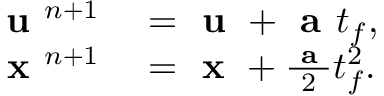<formula> <loc_0><loc_0><loc_500><loc_500>\begin{array} { r l } { u ^ { n + 1 } } & = u + a t _ { f } , } \\ { x ^ { n + 1 } } & = x + \frac { a } { 2 } t _ { f } ^ { 2 } . } \end{array}</formula> 